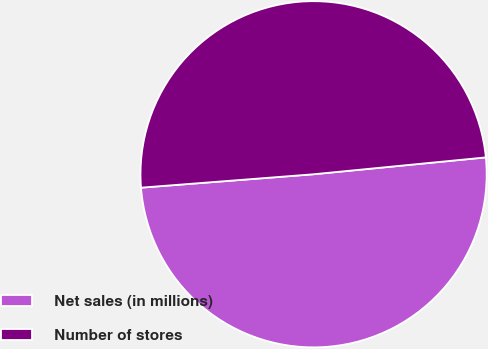Convert chart. <chart><loc_0><loc_0><loc_500><loc_500><pie_chart><fcel>Net sales (in millions)<fcel>Number of stores<nl><fcel>50.32%<fcel>49.68%<nl></chart> 